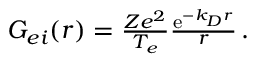Convert formula to latex. <formula><loc_0><loc_0><loc_500><loc_500>\begin{array} { r } { G _ { e i } ( r ) = \frac { Z e ^ { 2 } } { T _ { e } } \frac { e ^ { - k _ { D } r } } { r } \, . } \end{array}</formula> 